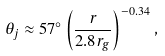Convert formula to latex. <formula><loc_0><loc_0><loc_500><loc_500>\theta _ { j } \approx 5 7 ^ { \circ } \left ( \frac { r } { 2 . 8 r _ { g } } \right ) ^ { - 0 . 3 4 } ,</formula> 